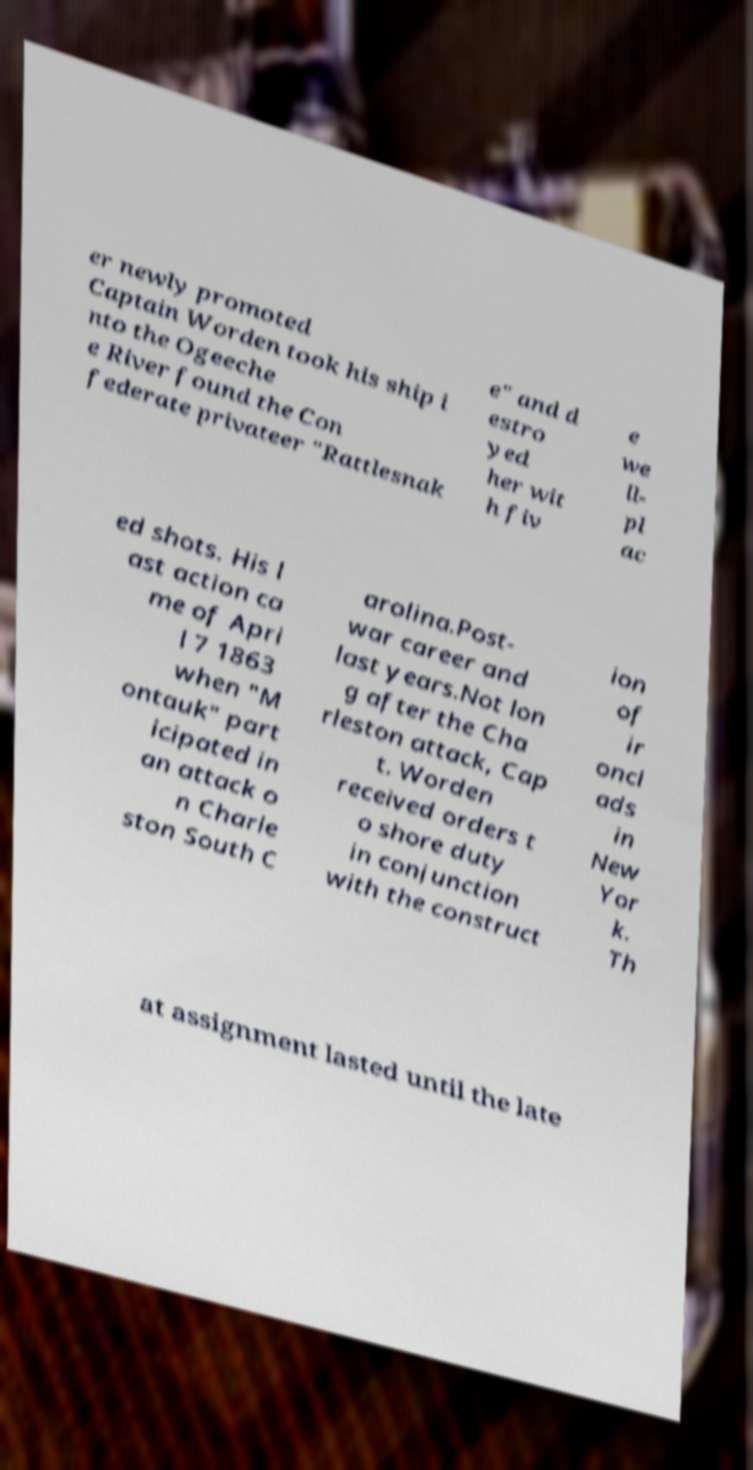Please identify and transcribe the text found in this image. er newly promoted Captain Worden took his ship i nto the Ogeeche e River found the Con federate privateer "Rattlesnak e" and d estro yed her wit h fiv e we ll- pl ac ed shots. His l ast action ca me of Apri l 7 1863 when "M ontauk" part icipated in an attack o n Charle ston South C arolina.Post- war career and last years.Not lon g after the Cha rleston attack, Cap t. Worden received orders t o shore duty in conjunction with the construct ion of ir oncl ads in New Yor k. Th at assignment lasted until the late 